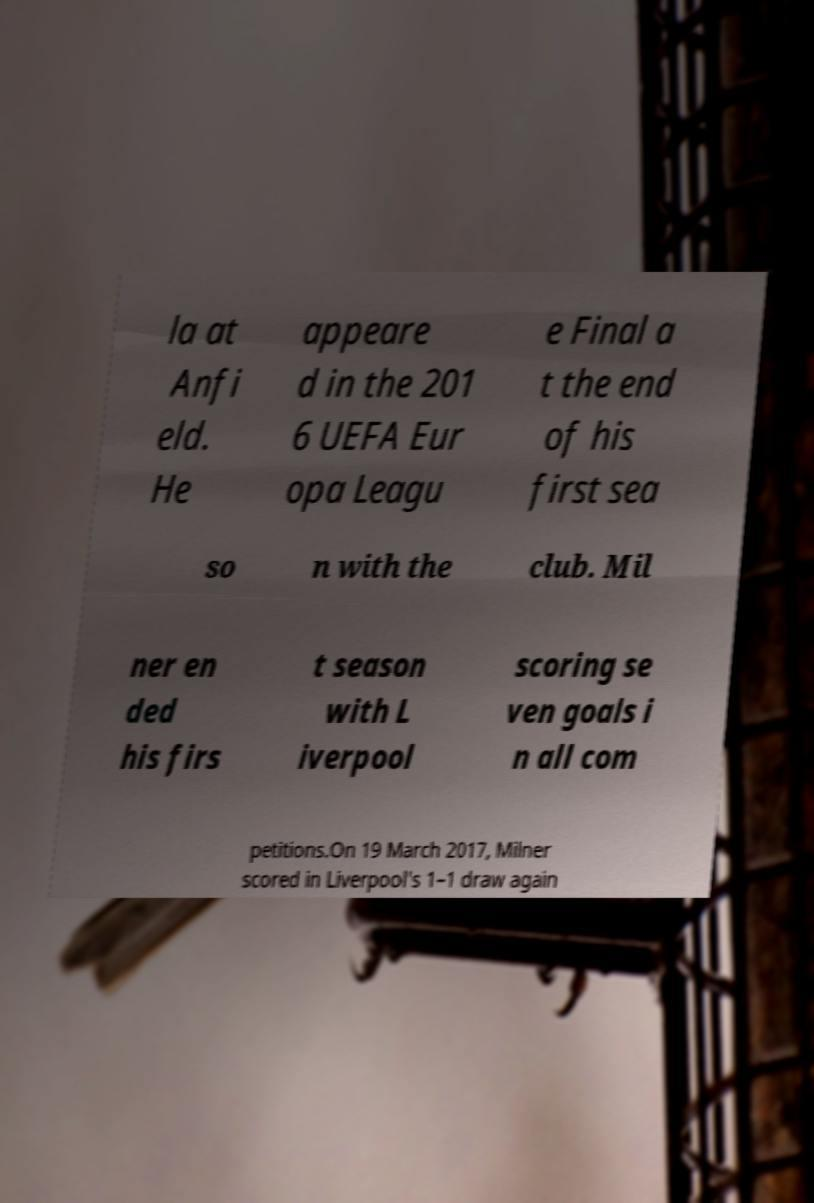I need the written content from this picture converted into text. Can you do that? la at Anfi eld. He appeare d in the 201 6 UEFA Eur opa Leagu e Final a t the end of his first sea so n with the club. Mil ner en ded his firs t season with L iverpool scoring se ven goals i n all com petitions.On 19 March 2017, Milner scored in Liverpool's 1–1 draw again 